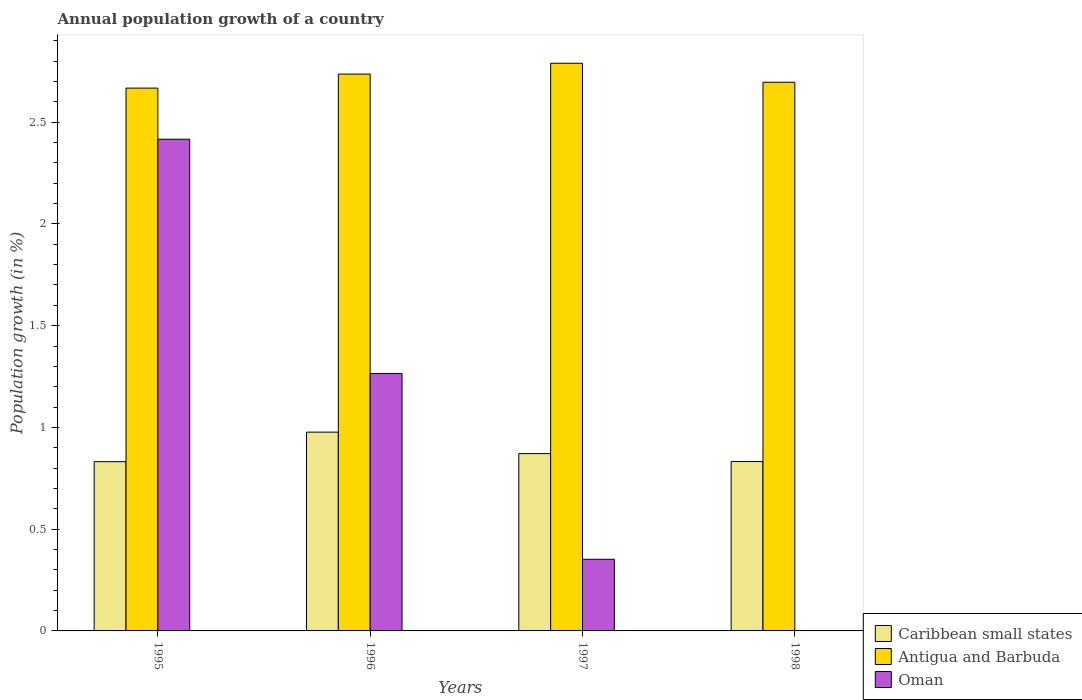How many different coloured bars are there?
Provide a short and direct response. 3. How many groups of bars are there?
Provide a succinct answer. 4. Are the number of bars on each tick of the X-axis equal?
Ensure brevity in your answer.  No. How many bars are there on the 4th tick from the left?
Keep it short and to the point. 2. How many bars are there on the 1st tick from the right?
Ensure brevity in your answer.  2. What is the annual population growth in Caribbean small states in 1996?
Keep it short and to the point. 0.98. Across all years, what is the maximum annual population growth in Oman?
Provide a short and direct response. 2.42. Across all years, what is the minimum annual population growth in Antigua and Barbuda?
Provide a succinct answer. 2.67. What is the total annual population growth in Oman in the graph?
Your answer should be compact. 4.03. What is the difference between the annual population growth in Oman in 1995 and that in 1997?
Give a very brief answer. 2.06. What is the difference between the annual population growth in Caribbean small states in 1996 and the annual population growth in Antigua and Barbuda in 1995?
Your answer should be compact. -1.69. What is the average annual population growth in Antigua and Barbuda per year?
Offer a terse response. 2.72. In the year 1996, what is the difference between the annual population growth in Oman and annual population growth in Caribbean small states?
Your answer should be compact. 0.29. In how many years, is the annual population growth in Antigua and Barbuda greater than 0.6 %?
Your answer should be very brief. 4. What is the ratio of the annual population growth in Antigua and Barbuda in 1995 to that in 1997?
Your answer should be very brief. 0.96. Is the difference between the annual population growth in Oman in 1995 and 1996 greater than the difference between the annual population growth in Caribbean small states in 1995 and 1996?
Provide a short and direct response. Yes. What is the difference between the highest and the second highest annual population growth in Antigua and Barbuda?
Give a very brief answer. 0.05. What is the difference between the highest and the lowest annual population growth in Oman?
Give a very brief answer. 2.42. Is it the case that in every year, the sum of the annual population growth in Caribbean small states and annual population growth in Antigua and Barbuda is greater than the annual population growth in Oman?
Give a very brief answer. Yes. How many bars are there?
Provide a short and direct response. 11. Are all the bars in the graph horizontal?
Provide a succinct answer. No. How many years are there in the graph?
Offer a terse response. 4. What is the difference between two consecutive major ticks on the Y-axis?
Provide a short and direct response. 0.5. Are the values on the major ticks of Y-axis written in scientific E-notation?
Provide a short and direct response. No. Where does the legend appear in the graph?
Provide a succinct answer. Bottom right. What is the title of the graph?
Provide a succinct answer. Annual population growth of a country. Does "Iraq" appear as one of the legend labels in the graph?
Make the answer very short. No. What is the label or title of the X-axis?
Keep it short and to the point. Years. What is the label or title of the Y-axis?
Your answer should be compact. Population growth (in %). What is the Population growth (in %) in Caribbean small states in 1995?
Your answer should be very brief. 0.83. What is the Population growth (in %) of Antigua and Barbuda in 1995?
Give a very brief answer. 2.67. What is the Population growth (in %) of Oman in 1995?
Your answer should be compact. 2.42. What is the Population growth (in %) in Caribbean small states in 1996?
Your answer should be very brief. 0.98. What is the Population growth (in %) of Antigua and Barbuda in 1996?
Your answer should be compact. 2.74. What is the Population growth (in %) in Oman in 1996?
Your answer should be compact. 1.27. What is the Population growth (in %) in Caribbean small states in 1997?
Offer a very short reply. 0.87. What is the Population growth (in %) of Antigua and Barbuda in 1997?
Your answer should be compact. 2.79. What is the Population growth (in %) of Oman in 1997?
Your response must be concise. 0.35. What is the Population growth (in %) of Caribbean small states in 1998?
Offer a very short reply. 0.83. What is the Population growth (in %) of Antigua and Barbuda in 1998?
Your answer should be very brief. 2.7. Across all years, what is the maximum Population growth (in %) of Caribbean small states?
Ensure brevity in your answer.  0.98. Across all years, what is the maximum Population growth (in %) of Antigua and Barbuda?
Make the answer very short. 2.79. Across all years, what is the maximum Population growth (in %) in Oman?
Your answer should be compact. 2.42. Across all years, what is the minimum Population growth (in %) of Caribbean small states?
Offer a very short reply. 0.83. Across all years, what is the minimum Population growth (in %) of Antigua and Barbuda?
Offer a very short reply. 2.67. Across all years, what is the minimum Population growth (in %) of Oman?
Provide a succinct answer. 0. What is the total Population growth (in %) in Caribbean small states in the graph?
Give a very brief answer. 3.51. What is the total Population growth (in %) of Antigua and Barbuda in the graph?
Keep it short and to the point. 10.89. What is the total Population growth (in %) of Oman in the graph?
Offer a terse response. 4.03. What is the difference between the Population growth (in %) of Caribbean small states in 1995 and that in 1996?
Your answer should be compact. -0.15. What is the difference between the Population growth (in %) of Antigua and Barbuda in 1995 and that in 1996?
Provide a succinct answer. -0.07. What is the difference between the Population growth (in %) in Oman in 1995 and that in 1996?
Ensure brevity in your answer.  1.15. What is the difference between the Population growth (in %) in Caribbean small states in 1995 and that in 1997?
Make the answer very short. -0.04. What is the difference between the Population growth (in %) in Antigua and Barbuda in 1995 and that in 1997?
Provide a short and direct response. -0.12. What is the difference between the Population growth (in %) in Oman in 1995 and that in 1997?
Offer a very short reply. 2.06. What is the difference between the Population growth (in %) of Caribbean small states in 1995 and that in 1998?
Give a very brief answer. -0. What is the difference between the Population growth (in %) of Antigua and Barbuda in 1995 and that in 1998?
Make the answer very short. -0.03. What is the difference between the Population growth (in %) in Caribbean small states in 1996 and that in 1997?
Make the answer very short. 0.11. What is the difference between the Population growth (in %) of Antigua and Barbuda in 1996 and that in 1997?
Your answer should be very brief. -0.05. What is the difference between the Population growth (in %) in Caribbean small states in 1996 and that in 1998?
Provide a short and direct response. 0.14. What is the difference between the Population growth (in %) in Antigua and Barbuda in 1996 and that in 1998?
Ensure brevity in your answer.  0.04. What is the difference between the Population growth (in %) of Caribbean small states in 1997 and that in 1998?
Your answer should be compact. 0.04. What is the difference between the Population growth (in %) of Antigua and Barbuda in 1997 and that in 1998?
Give a very brief answer. 0.09. What is the difference between the Population growth (in %) of Caribbean small states in 1995 and the Population growth (in %) of Antigua and Barbuda in 1996?
Keep it short and to the point. -1.9. What is the difference between the Population growth (in %) in Caribbean small states in 1995 and the Population growth (in %) in Oman in 1996?
Make the answer very short. -0.43. What is the difference between the Population growth (in %) of Antigua and Barbuda in 1995 and the Population growth (in %) of Oman in 1996?
Offer a terse response. 1.4. What is the difference between the Population growth (in %) of Caribbean small states in 1995 and the Population growth (in %) of Antigua and Barbuda in 1997?
Your response must be concise. -1.96. What is the difference between the Population growth (in %) of Caribbean small states in 1995 and the Population growth (in %) of Oman in 1997?
Your answer should be compact. 0.48. What is the difference between the Population growth (in %) in Antigua and Barbuda in 1995 and the Population growth (in %) in Oman in 1997?
Make the answer very short. 2.32. What is the difference between the Population growth (in %) in Caribbean small states in 1995 and the Population growth (in %) in Antigua and Barbuda in 1998?
Give a very brief answer. -1.86. What is the difference between the Population growth (in %) in Caribbean small states in 1996 and the Population growth (in %) in Antigua and Barbuda in 1997?
Give a very brief answer. -1.81. What is the difference between the Population growth (in %) of Caribbean small states in 1996 and the Population growth (in %) of Oman in 1997?
Provide a short and direct response. 0.62. What is the difference between the Population growth (in %) of Antigua and Barbuda in 1996 and the Population growth (in %) of Oman in 1997?
Offer a terse response. 2.38. What is the difference between the Population growth (in %) of Caribbean small states in 1996 and the Population growth (in %) of Antigua and Barbuda in 1998?
Make the answer very short. -1.72. What is the difference between the Population growth (in %) in Caribbean small states in 1997 and the Population growth (in %) in Antigua and Barbuda in 1998?
Provide a succinct answer. -1.82. What is the average Population growth (in %) in Caribbean small states per year?
Provide a short and direct response. 0.88. What is the average Population growth (in %) of Antigua and Barbuda per year?
Give a very brief answer. 2.72. What is the average Population growth (in %) of Oman per year?
Keep it short and to the point. 1.01. In the year 1995, what is the difference between the Population growth (in %) of Caribbean small states and Population growth (in %) of Antigua and Barbuda?
Give a very brief answer. -1.84. In the year 1995, what is the difference between the Population growth (in %) of Caribbean small states and Population growth (in %) of Oman?
Make the answer very short. -1.58. In the year 1995, what is the difference between the Population growth (in %) of Antigua and Barbuda and Population growth (in %) of Oman?
Make the answer very short. 0.25. In the year 1996, what is the difference between the Population growth (in %) of Caribbean small states and Population growth (in %) of Antigua and Barbuda?
Your answer should be compact. -1.76. In the year 1996, what is the difference between the Population growth (in %) in Caribbean small states and Population growth (in %) in Oman?
Your response must be concise. -0.29. In the year 1996, what is the difference between the Population growth (in %) of Antigua and Barbuda and Population growth (in %) of Oman?
Offer a very short reply. 1.47. In the year 1997, what is the difference between the Population growth (in %) of Caribbean small states and Population growth (in %) of Antigua and Barbuda?
Keep it short and to the point. -1.92. In the year 1997, what is the difference between the Population growth (in %) of Caribbean small states and Population growth (in %) of Oman?
Ensure brevity in your answer.  0.52. In the year 1997, what is the difference between the Population growth (in %) in Antigua and Barbuda and Population growth (in %) in Oman?
Your answer should be compact. 2.44. In the year 1998, what is the difference between the Population growth (in %) in Caribbean small states and Population growth (in %) in Antigua and Barbuda?
Provide a succinct answer. -1.86. What is the ratio of the Population growth (in %) in Caribbean small states in 1995 to that in 1996?
Offer a terse response. 0.85. What is the ratio of the Population growth (in %) in Antigua and Barbuda in 1995 to that in 1996?
Keep it short and to the point. 0.97. What is the ratio of the Population growth (in %) in Oman in 1995 to that in 1996?
Your answer should be very brief. 1.91. What is the ratio of the Population growth (in %) in Caribbean small states in 1995 to that in 1997?
Provide a short and direct response. 0.95. What is the ratio of the Population growth (in %) in Antigua and Barbuda in 1995 to that in 1997?
Provide a short and direct response. 0.96. What is the ratio of the Population growth (in %) of Oman in 1995 to that in 1997?
Ensure brevity in your answer.  6.86. What is the ratio of the Population growth (in %) of Antigua and Barbuda in 1995 to that in 1998?
Offer a terse response. 0.99. What is the ratio of the Population growth (in %) of Caribbean small states in 1996 to that in 1997?
Make the answer very short. 1.12. What is the ratio of the Population growth (in %) of Antigua and Barbuda in 1996 to that in 1997?
Keep it short and to the point. 0.98. What is the ratio of the Population growth (in %) of Oman in 1996 to that in 1997?
Your answer should be compact. 3.59. What is the ratio of the Population growth (in %) in Caribbean small states in 1996 to that in 1998?
Keep it short and to the point. 1.17. What is the ratio of the Population growth (in %) in Antigua and Barbuda in 1996 to that in 1998?
Keep it short and to the point. 1.01. What is the ratio of the Population growth (in %) in Caribbean small states in 1997 to that in 1998?
Your response must be concise. 1.05. What is the ratio of the Population growth (in %) in Antigua and Barbuda in 1997 to that in 1998?
Provide a short and direct response. 1.03. What is the difference between the highest and the second highest Population growth (in %) in Caribbean small states?
Your answer should be compact. 0.11. What is the difference between the highest and the second highest Population growth (in %) in Antigua and Barbuda?
Give a very brief answer. 0.05. What is the difference between the highest and the second highest Population growth (in %) in Oman?
Your answer should be very brief. 1.15. What is the difference between the highest and the lowest Population growth (in %) of Caribbean small states?
Provide a succinct answer. 0.15. What is the difference between the highest and the lowest Population growth (in %) in Antigua and Barbuda?
Keep it short and to the point. 0.12. What is the difference between the highest and the lowest Population growth (in %) of Oman?
Provide a succinct answer. 2.42. 